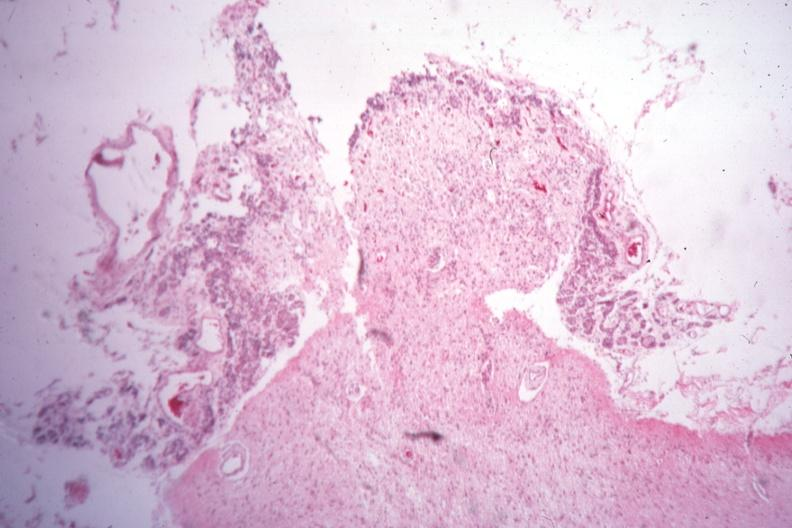where is this part in the figure?
Answer the question using a single word or phrase. Endocrine system 